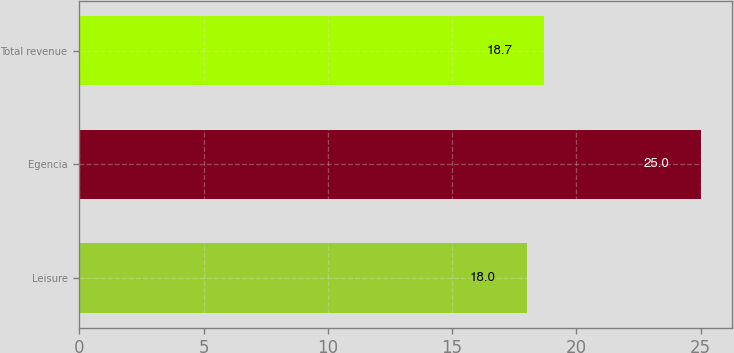Convert chart to OTSL. <chart><loc_0><loc_0><loc_500><loc_500><bar_chart><fcel>Leisure<fcel>Egencia<fcel>Total revenue<nl><fcel>18<fcel>25<fcel>18.7<nl></chart> 